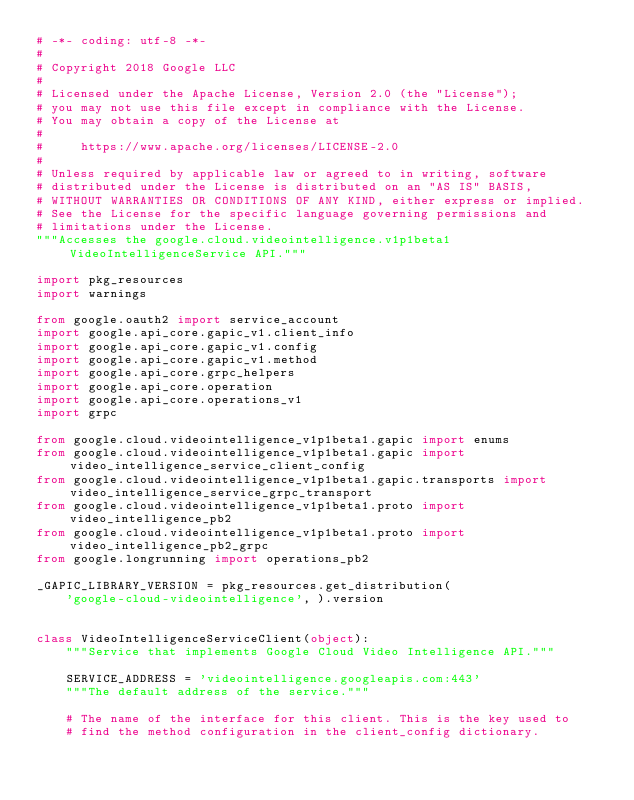Convert code to text. <code><loc_0><loc_0><loc_500><loc_500><_Python_># -*- coding: utf-8 -*-
#
# Copyright 2018 Google LLC
#
# Licensed under the Apache License, Version 2.0 (the "License");
# you may not use this file except in compliance with the License.
# You may obtain a copy of the License at
#
#     https://www.apache.org/licenses/LICENSE-2.0
#
# Unless required by applicable law or agreed to in writing, software
# distributed under the License is distributed on an "AS IS" BASIS,
# WITHOUT WARRANTIES OR CONDITIONS OF ANY KIND, either express or implied.
# See the License for the specific language governing permissions and
# limitations under the License.
"""Accesses the google.cloud.videointelligence.v1p1beta1 VideoIntelligenceService API."""

import pkg_resources
import warnings

from google.oauth2 import service_account
import google.api_core.gapic_v1.client_info
import google.api_core.gapic_v1.config
import google.api_core.gapic_v1.method
import google.api_core.grpc_helpers
import google.api_core.operation
import google.api_core.operations_v1
import grpc

from google.cloud.videointelligence_v1p1beta1.gapic import enums
from google.cloud.videointelligence_v1p1beta1.gapic import video_intelligence_service_client_config
from google.cloud.videointelligence_v1p1beta1.gapic.transports import video_intelligence_service_grpc_transport
from google.cloud.videointelligence_v1p1beta1.proto import video_intelligence_pb2
from google.cloud.videointelligence_v1p1beta1.proto import video_intelligence_pb2_grpc
from google.longrunning import operations_pb2

_GAPIC_LIBRARY_VERSION = pkg_resources.get_distribution(
    'google-cloud-videointelligence', ).version


class VideoIntelligenceServiceClient(object):
    """Service that implements Google Cloud Video Intelligence API."""

    SERVICE_ADDRESS = 'videointelligence.googleapis.com:443'
    """The default address of the service."""

    # The name of the interface for this client. This is the key used to
    # find the method configuration in the client_config dictionary.</code> 